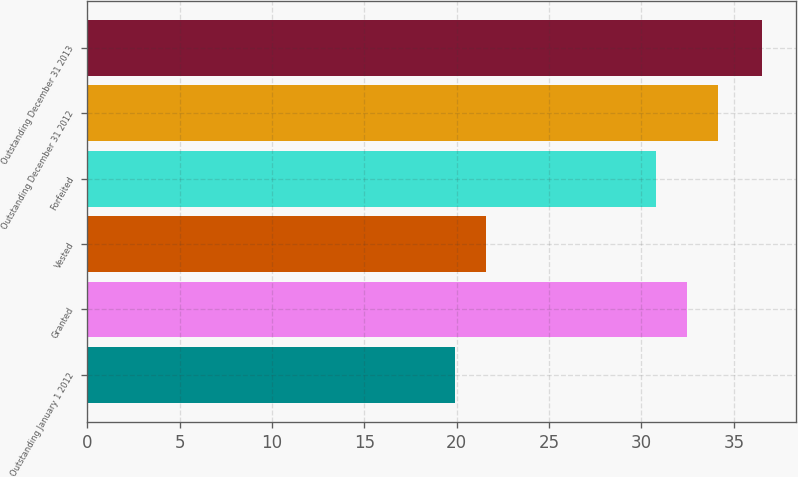Convert chart. <chart><loc_0><loc_0><loc_500><loc_500><bar_chart><fcel>Outstanding January 1 2012<fcel>Granted<fcel>Vested<fcel>Forfeited<fcel>Outstanding December 31 2012<fcel>Outstanding December 31 2013<nl><fcel>19.9<fcel>32.48<fcel>21.56<fcel>30.81<fcel>34.14<fcel>36.55<nl></chart> 